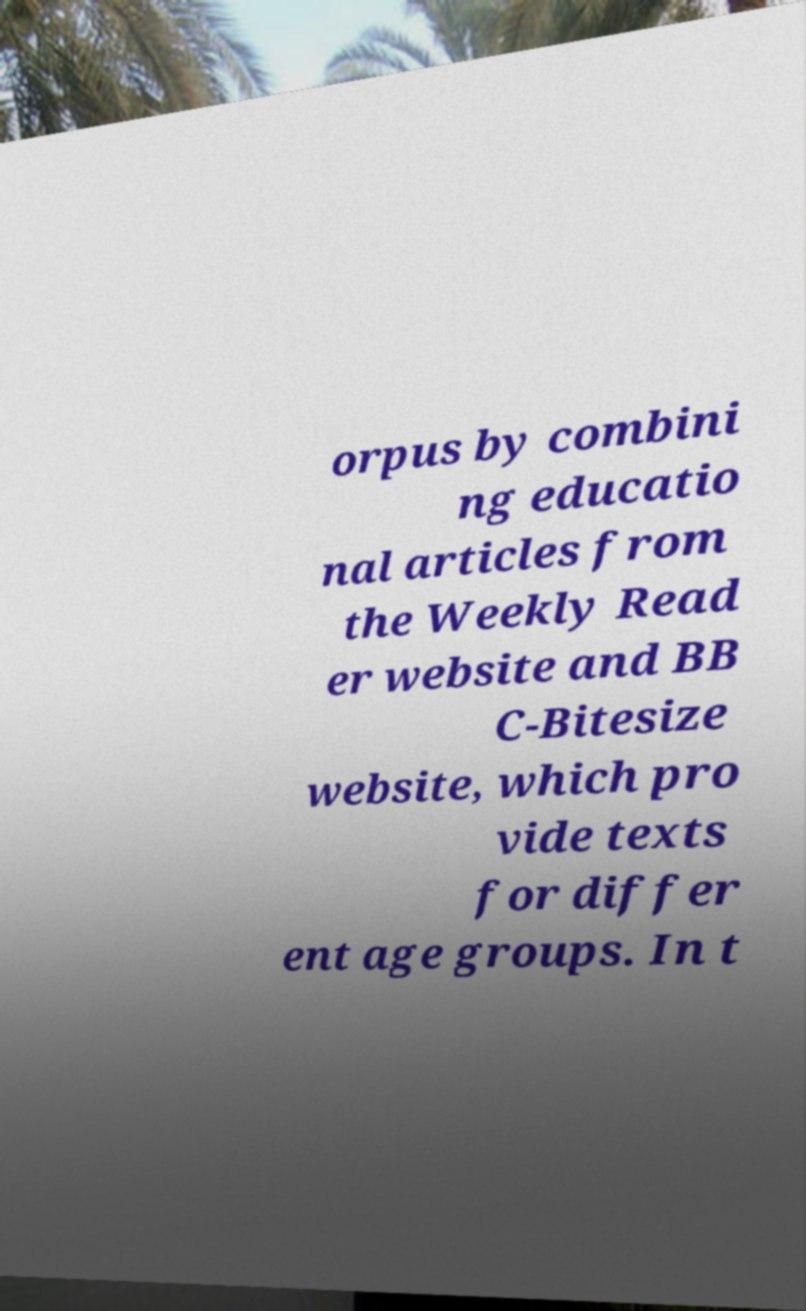What messages or text are displayed in this image? I need them in a readable, typed format. orpus by combini ng educatio nal articles from the Weekly Read er website and BB C-Bitesize website, which pro vide texts for differ ent age groups. In t 